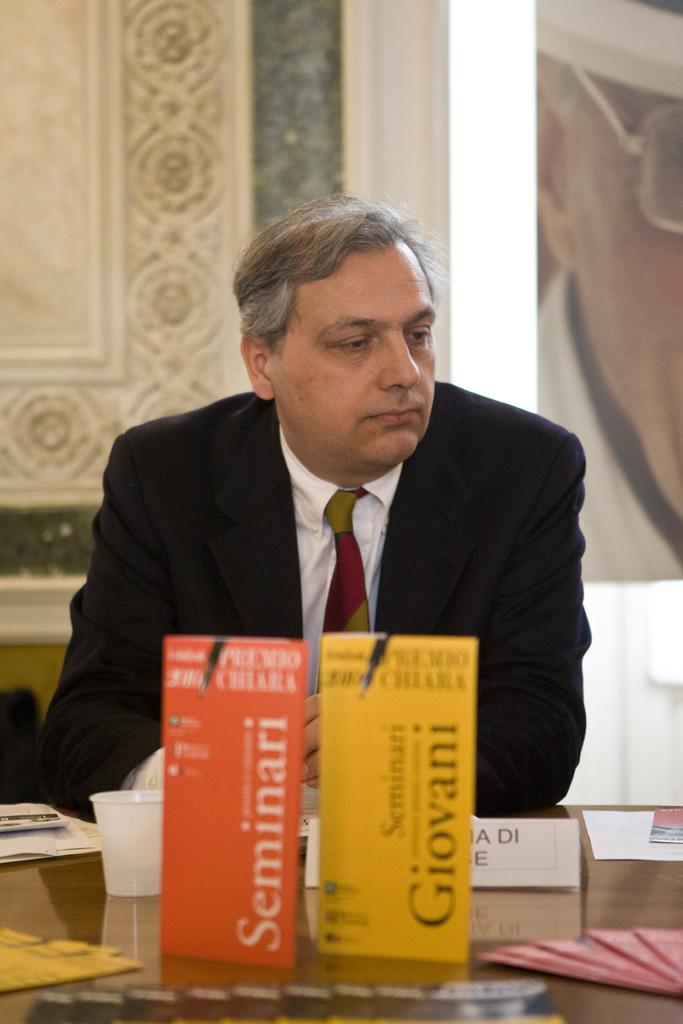<image>
Summarize the visual content of the image. A man sits at a table where two books titled Seminari and Giovani are displayed. 